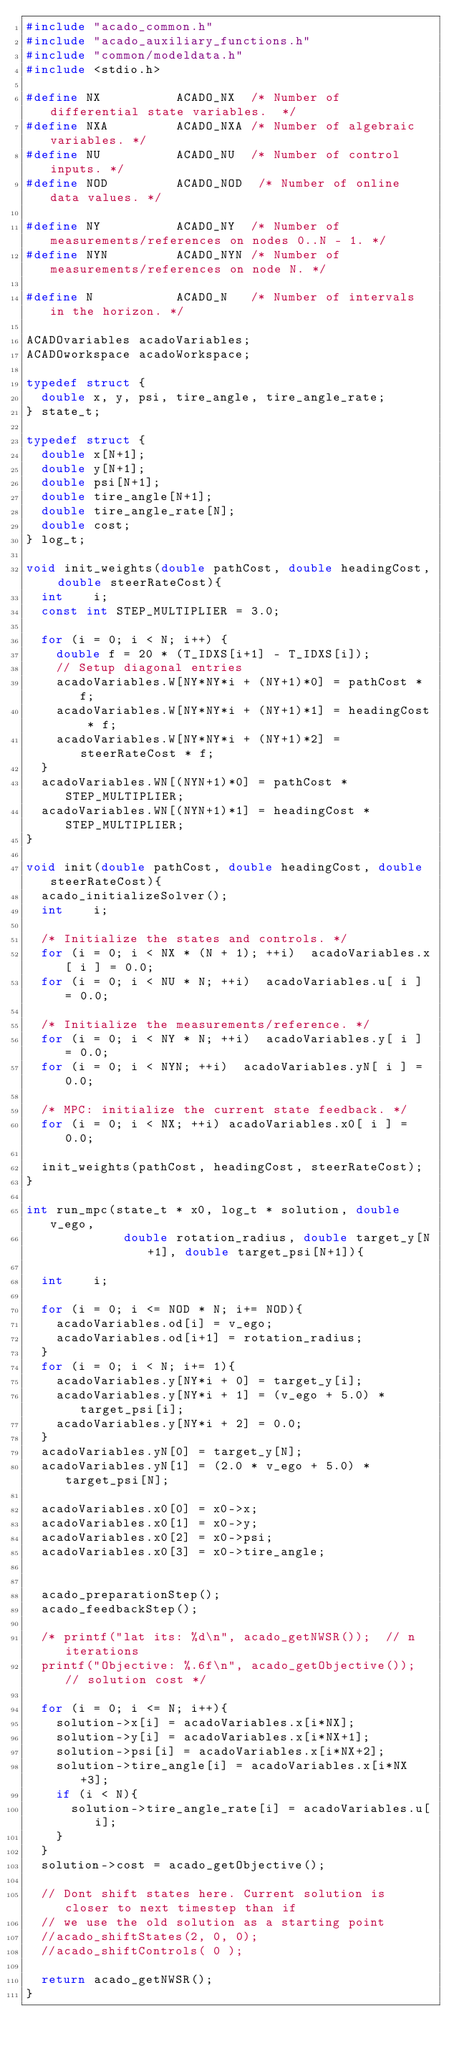Convert code to text. <code><loc_0><loc_0><loc_500><loc_500><_C_>#include "acado_common.h"
#include "acado_auxiliary_functions.h"
#include "common/modeldata.h"
#include <stdio.h>

#define NX          ACADO_NX  /* Number of differential state variables.  */
#define NXA         ACADO_NXA /* Number of algebraic variables. */
#define NU          ACADO_NU  /* Number of control inputs. */
#define NOD         ACADO_NOD  /* Number of online data values. */

#define NY          ACADO_NY  /* Number of measurements/references on nodes 0..N - 1. */
#define NYN         ACADO_NYN /* Number of measurements/references on node N. */

#define N           ACADO_N   /* Number of intervals in the horizon. */

ACADOvariables acadoVariables;
ACADOworkspace acadoWorkspace;

typedef struct {
  double x, y, psi, tire_angle, tire_angle_rate;
} state_t;

typedef struct {
  double x[N+1];
  double y[N+1];
  double psi[N+1];
  double tire_angle[N+1];
  double tire_angle_rate[N];
  double cost;
} log_t;

void init_weights(double pathCost, double headingCost, double steerRateCost){
  int    i;
  const int STEP_MULTIPLIER = 3.0;

  for (i = 0; i < N; i++) {
    double f = 20 * (T_IDXS[i+1] - T_IDXS[i]);
    // Setup diagonal entries
    acadoVariables.W[NY*NY*i + (NY+1)*0] = pathCost * f;
    acadoVariables.W[NY*NY*i + (NY+1)*1] = headingCost * f;
    acadoVariables.W[NY*NY*i + (NY+1)*2] = steerRateCost * f;
  }
  acadoVariables.WN[(NYN+1)*0] = pathCost * STEP_MULTIPLIER;
  acadoVariables.WN[(NYN+1)*1] = headingCost * STEP_MULTIPLIER;
}

void init(double pathCost, double headingCost, double steerRateCost){
  acado_initializeSolver();
  int    i;

  /* Initialize the states and controls. */
  for (i = 0; i < NX * (N + 1); ++i)  acadoVariables.x[ i ] = 0.0;
  for (i = 0; i < NU * N; ++i)  acadoVariables.u[ i ] = 0.0;

  /* Initialize the measurements/reference. */
  for (i = 0; i < NY * N; ++i)  acadoVariables.y[ i ] = 0.0;
  for (i = 0; i < NYN; ++i)  acadoVariables.yN[ i ] = 0.0;

  /* MPC: initialize the current state feedback. */
  for (i = 0; i < NX; ++i) acadoVariables.x0[ i ] = 0.0;

  init_weights(pathCost, headingCost, steerRateCost);
}

int run_mpc(state_t * x0, log_t * solution, double v_ego,
             double rotation_radius, double target_y[N+1], double target_psi[N+1]){

  int    i;

  for (i = 0; i <= NOD * N; i+= NOD){
    acadoVariables.od[i] = v_ego;
    acadoVariables.od[i+1] = rotation_radius;
  }
  for (i = 0; i < N; i+= 1){
    acadoVariables.y[NY*i + 0] = target_y[i];
    acadoVariables.y[NY*i + 1] = (v_ego + 5.0) * target_psi[i];
    acadoVariables.y[NY*i + 2] = 0.0;
  }
  acadoVariables.yN[0] = target_y[N];
  acadoVariables.yN[1] = (2.0 * v_ego + 5.0) * target_psi[N];

  acadoVariables.x0[0] = x0->x;
  acadoVariables.x0[1] = x0->y;
  acadoVariables.x0[2] = x0->psi;
  acadoVariables.x0[3] = x0->tire_angle;


  acado_preparationStep();
  acado_feedbackStep();

  /* printf("lat its: %d\n", acado_getNWSR());  // n iterations
  printf("Objective: %.6f\n", acado_getObjective());  // solution cost */

  for (i = 0; i <= N; i++){
    solution->x[i] = acadoVariables.x[i*NX];
    solution->y[i] = acadoVariables.x[i*NX+1];
    solution->psi[i] = acadoVariables.x[i*NX+2];
    solution->tire_angle[i] = acadoVariables.x[i*NX+3];
    if (i < N){
      solution->tire_angle_rate[i] = acadoVariables.u[i];
    }
  }
  solution->cost = acado_getObjective();

  // Dont shift states here. Current solution is closer to next timestep than if
  // we use the old solution as a starting point
  //acado_shiftStates(2, 0, 0);
  //acado_shiftControls( 0 );

  return acado_getNWSR();
}
</code> 